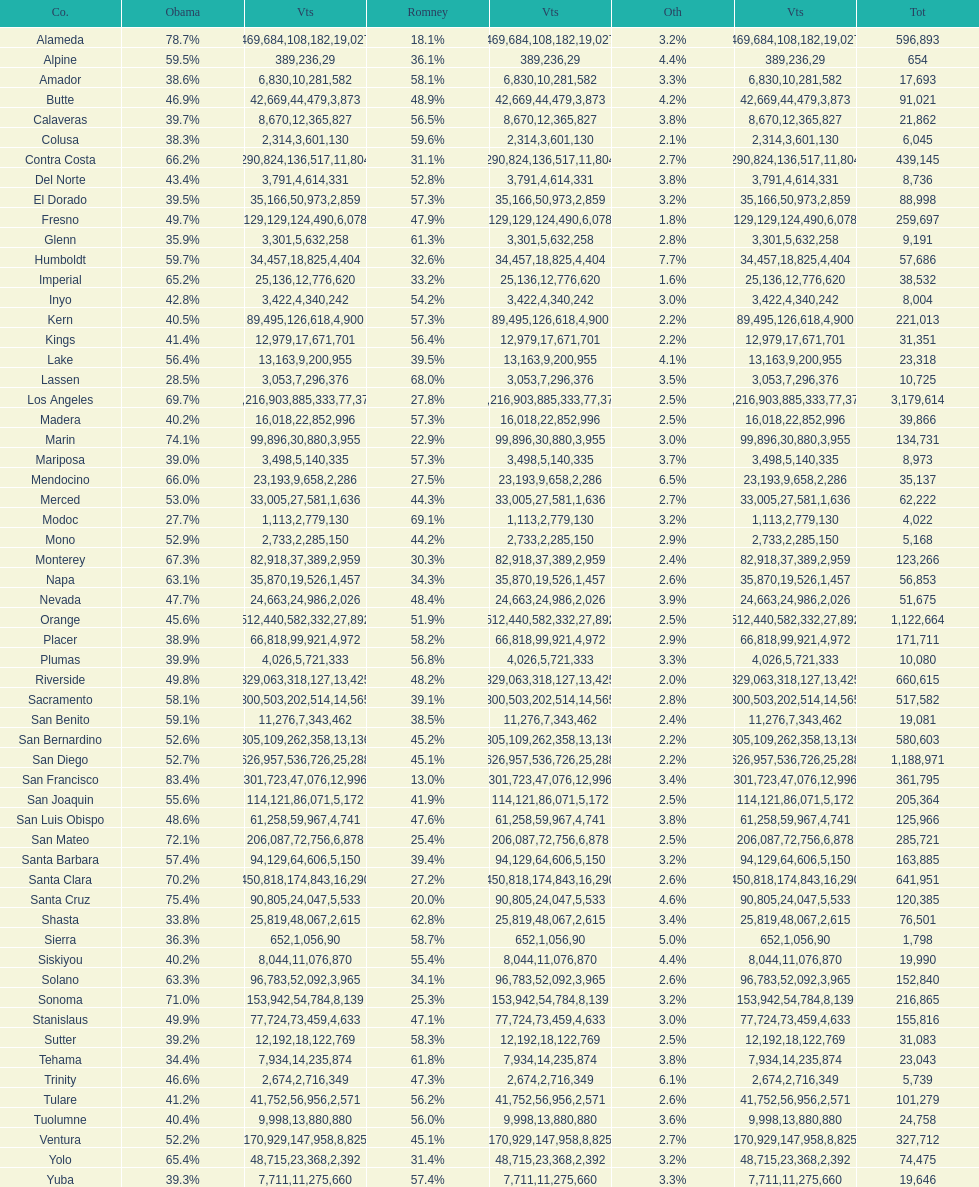Which county had the lower percentage votes for obama: amador, humboldt, or lake? Amador. Could you parse the entire table as a dict? {'header': ['Co.', 'Obama', 'Vts', 'Romney', 'Vts', 'Oth', 'Vts', 'Tot'], 'rows': [['Alameda', '78.7%', '469,684', '18.1%', '108,182', '3.2%', '19,027', '596,893'], ['Alpine', '59.5%', '389', '36.1%', '236', '4.4%', '29', '654'], ['Amador', '38.6%', '6,830', '58.1%', '10,281', '3.3%', '582', '17,693'], ['Butte', '46.9%', '42,669', '48.9%', '44,479', '4.2%', '3,873', '91,021'], ['Calaveras', '39.7%', '8,670', '56.5%', '12,365', '3.8%', '827', '21,862'], ['Colusa', '38.3%', '2,314', '59.6%', '3,601', '2.1%', '130', '6,045'], ['Contra Costa', '66.2%', '290,824', '31.1%', '136,517', '2.7%', '11,804', '439,145'], ['Del Norte', '43.4%', '3,791', '52.8%', '4,614', '3.8%', '331', '8,736'], ['El Dorado', '39.5%', '35,166', '57.3%', '50,973', '3.2%', '2,859', '88,998'], ['Fresno', '49.7%', '129,129', '47.9%', '124,490', '1.8%', '6,078', '259,697'], ['Glenn', '35.9%', '3,301', '61.3%', '5,632', '2.8%', '258', '9,191'], ['Humboldt', '59.7%', '34,457', '32.6%', '18,825', '7.7%', '4,404', '57,686'], ['Imperial', '65.2%', '25,136', '33.2%', '12,776', '1.6%', '620', '38,532'], ['Inyo', '42.8%', '3,422', '54.2%', '4,340', '3.0%', '242', '8,004'], ['Kern', '40.5%', '89,495', '57.3%', '126,618', '2.2%', '4,900', '221,013'], ['Kings', '41.4%', '12,979', '56.4%', '17,671', '2.2%', '701', '31,351'], ['Lake', '56.4%', '13,163', '39.5%', '9,200', '4.1%', '955', '23,318'], ['Lassen', '28.5%', '3,053', '68.0%', '7,296', '3.5%', '376', '10,725'], ['Los Angeles', '69.7%', '2,216,903', '27.8%', '885,333', '2.5%', '77,378', '3,179,614'], ['Madera', '40.2%', '16,018', '57.3%', '22,852', '2.5%', '996', '39,866'], ['Marin', '74.1%', '99,896', '22.9%', '30,880', '3.0%', '3,955', '134,731'], ['Mariposa', '39.0%', '3,498', '57.3%', '5,140', '3.7%', '335', '8,973'], ['Mendocino', '66.0%', '23,193', '27.5%', '9,658', '6.5%', '2,286', '35,137'], ['Merced', '53.0%', '33,005', '44.3%', '27,581', '2.7%', '1,636', '62,222'], ['Modoc', '27.7%', '1,113', '69.1%', '2,779', '3.2%', '130', '4,022'], ['Mono', '52.9%', '2,733', '44.2%', '2,285', '2.9%', '150', '5,168'], ['Monterey', '67.3%', '82,918', '30.3%', '37,389', '2.4%', '2,959', '123,266'], ['Napa', '63.1%', '35,870', '34.3%', '19,526', '2.6%', '1,457', '56,853'], ['Nevada', '47.7%', '24,663', '48.4%', '24,986', '3.9%', '2,026', '51,675'], ['Orange', '45.6%', '512,440', '51.9%', '582,332', '2.5%', '27,892', '1,122,664'], ['Placer', '38.9%', '66,818', '58.2%', '99,921', '2.9%', '4,972', '171,711'], ['Plumas', '39.9%', '4,026', '56.8%', '5,721', '3.3%', '333', '10,080'], ['Riverside', '49.8%', '329,063', '48.2%', '318,127', '2.0%', '13,425', '660,615'], ['Sacramento', '58.1%', '300,503', '39.1%', '202,514', '2.8%', '14,565', '517,582'], ['San Benito', '59.1%', '11,276', '38.5%', '7,343', '2.4%', '462', '19,081'], ['San Bernardino', '52.6%', '305,109', '45.2%', '262,358', '2.2%', '13,136', '580,603'], ['San Diego', '52.7%', '626,957', '45.1%', '536,726', '2.2%', '25,288', '1,188,971'], ['San Francisco', '83.4%', '301,723', '13.0%', '47,076', '3.4%', '12,996', '361,795'], ['San Joaquin', '55.6%', '114,121', '41.9%', '86,071', '2.5%', '5,172', '205,364'], ['San Luis Obispo', '48.6%', '61,258', '47.6%', '59,967', '3.8%', '4,741', '125,966'], ['San Mateo', '72.1%', '206,087', '25.4%', '72,756', '2.5%', '6,878', '285,721'], ['Santa Barbara', '57.4%', '94,129', '39.4%', '64,606', '3.2%', '5,150', '163,885'], ['Santa Clara', '70.2%', '450,818', '27.2%', '174,843', '2.6%', '16,290', '641,951'], ['Santa Cruz', '75.4%', '90,805', '20.0%', '24,047', '4.6%', '5,533', '120,385'], ['Shasta', '33.8%', '25,819', '62.8%', '48,067', '3.4%', '2,615', '76,501'], ['Sierra', '36.3%', '652', '58.7%', '1,056', '5.0%', '90', '1,798'], ['Siskiyou', '40.2%', '8,044', '55.4%', '11,076', '4.4%', '870', '19,990'], ['Solano', '63.3%', '96,783', '34.1%', '52,092', '2.6%', '3,965', '152,840'], ['Sonoma', '71.0%', '153,942', '25.3%', '54,784', '3.2%', '8,139', '216,865'], ['Stanislaus', '49.9%', '77,724', '47.1%', '73,459', '3.0%', '4,633', '155,816'], ['Sutter', '39.2%', '12,192', '58.3%', '18,122', '2.5%', '769', '31,083'], ['Tehama', '34.4%', '7,934', '61.8%', '14,235', '3.8%', '874', '23,043'], ['Trinity', '46.6%', '2,674', '47.3%', '2,716', '6.1%', '349', '5,739'], ['Tulare', '41.2%', '41,752', '56.2%', '56,956', '2.6%', '2,571', '101,279'], ['Tuolumne', '40.4%', '9,998', '56.0%', '13,880', '3.6%', '880', '24,758'], ['Ventura', '52.2%', '170,929', '45.1%', '147,958', '2.7%', '8,825', '327,712'], ['Yolo', '65.4%', '48,715', '31.4%', '23,368', '3.2%', '2,392', '74,475'], ['Yuba', '39.3%', '7,711', '57.4%', '11,275', '3.3%', '660', '19,646']]} 